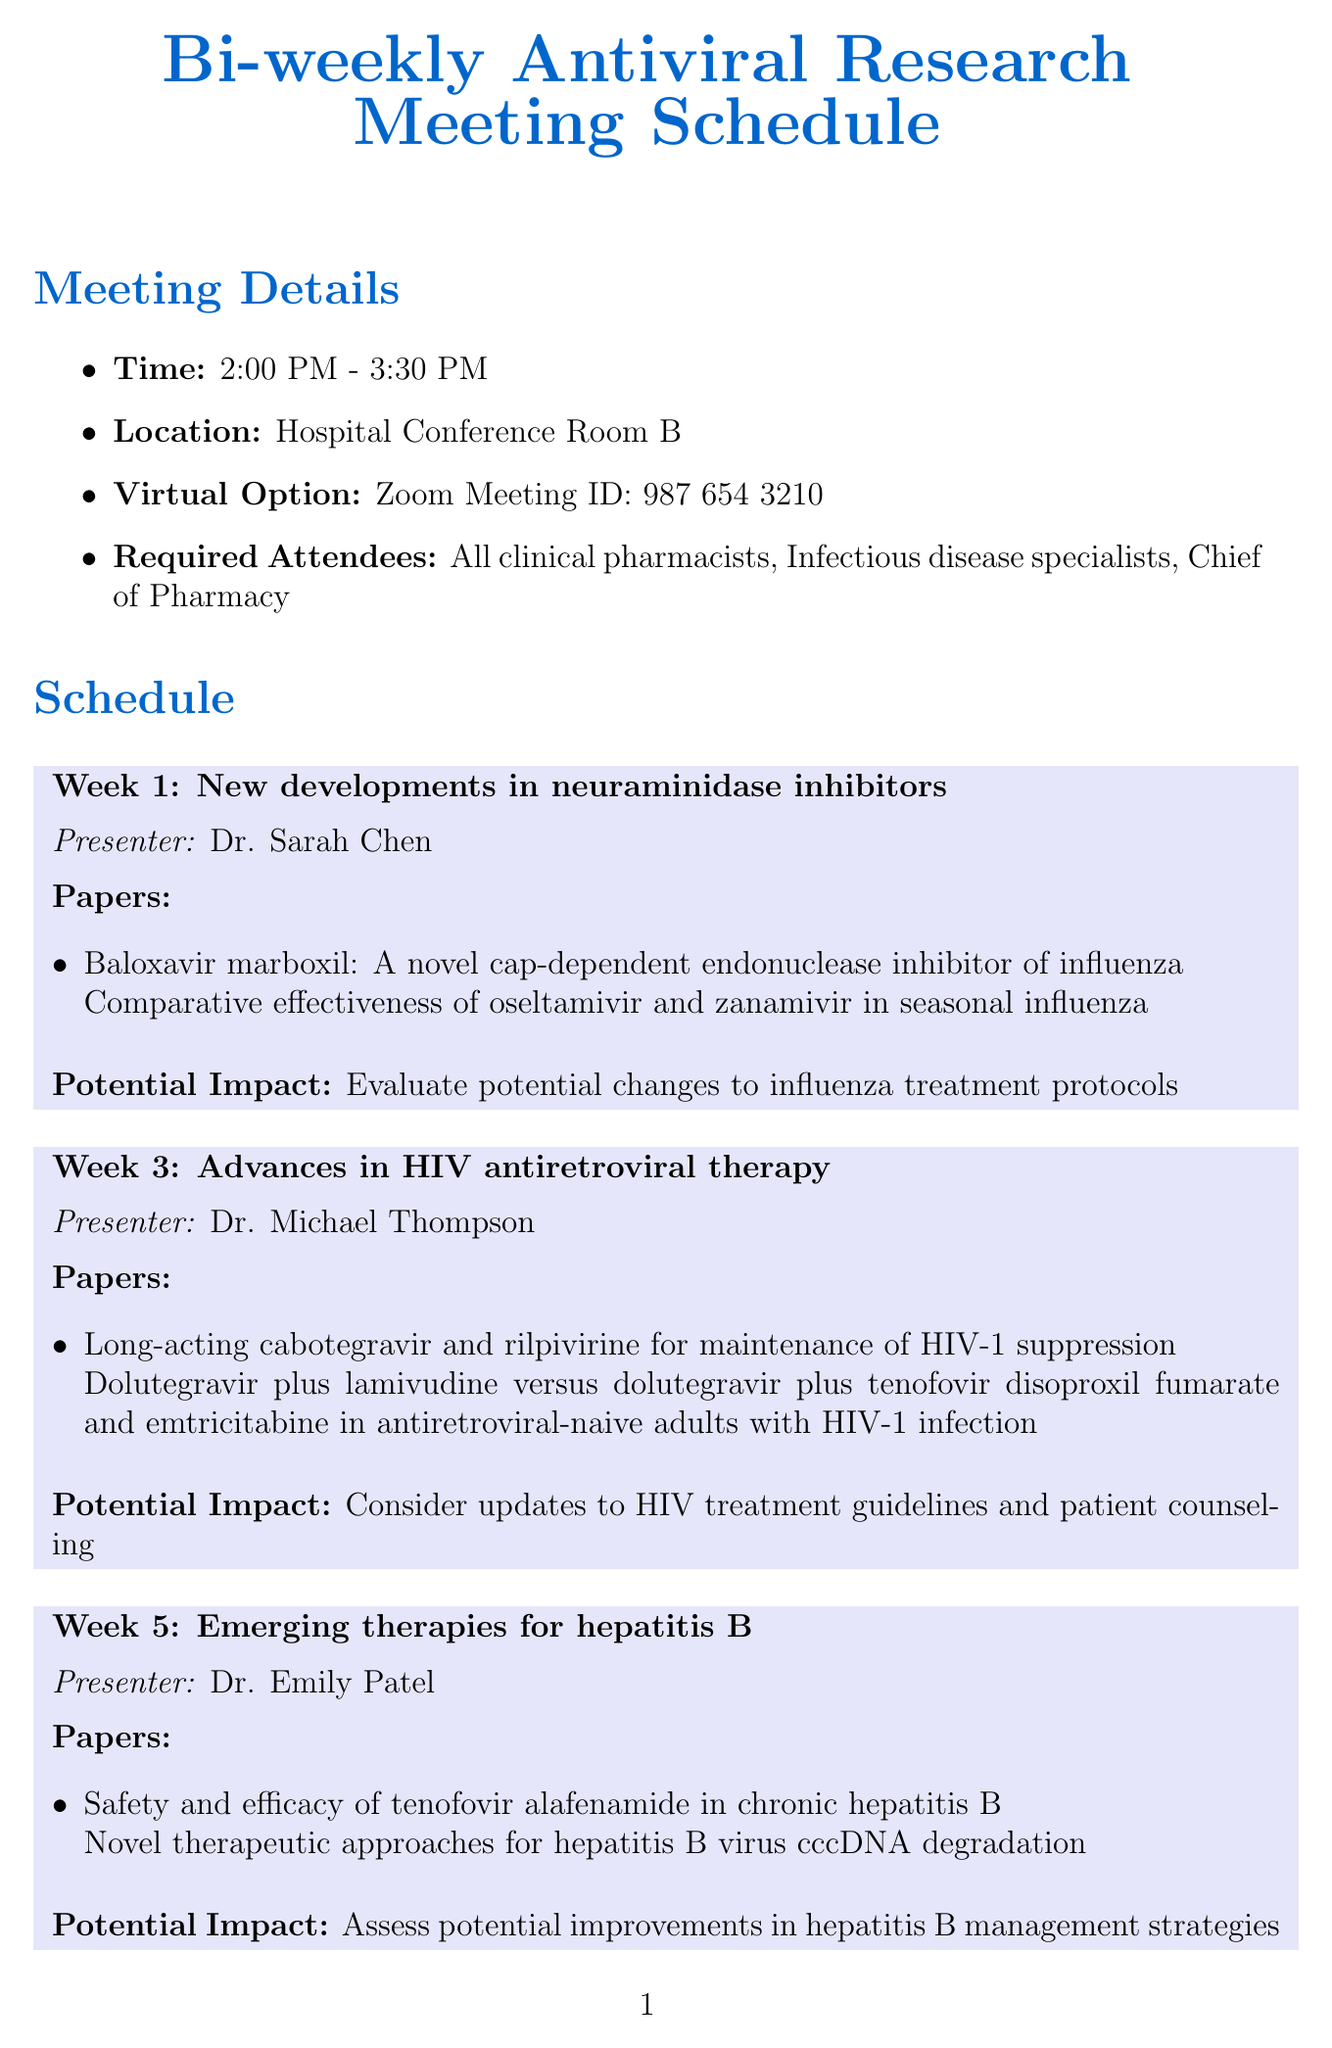What is the time of the meetings? The meeting details specify that the meetings are scheduled from 2:00 PM to 3:30 PM.
Answer: 2:00 PM - 3:30 PM Who is presenting in week 5? According to the schedule, Dr. Emily Patel is the presenter for week 5.
Answer: Dr. Emily Patel What is the topic for week 9? The schedule indicates that the topic for week 9 is antiviral resistance in herpes simplex virus.
Answer: Antiviral resistance in herpes simplex virus How many papers are discussed in week 1? The meeting for week 1 includes two papers.
Answer: 2 What is one of the action items listed? The document lists several action items, including updating the hospital formulary based on new evidence.
Answer: Update hospital formulary based on new evidence What is the virtual option for the meetings? The meeting details provide a Zoom Meeting ID for the virtual option.
Answer: Zoom Meeting ID: 987 654 3210 What potential impact is discussed in week 7? The potential impact for week 7 focuses on updating COVID-19 treatment protocols and patient education materials.
Answer: Update COVID-19 treatment protocols and patient education materials Which presenter discusses HIV therapies? Dr. Michael Thompson discusses HIV antiretroviral therapy in week 3.
Answer: Dr. Michael Thompson 